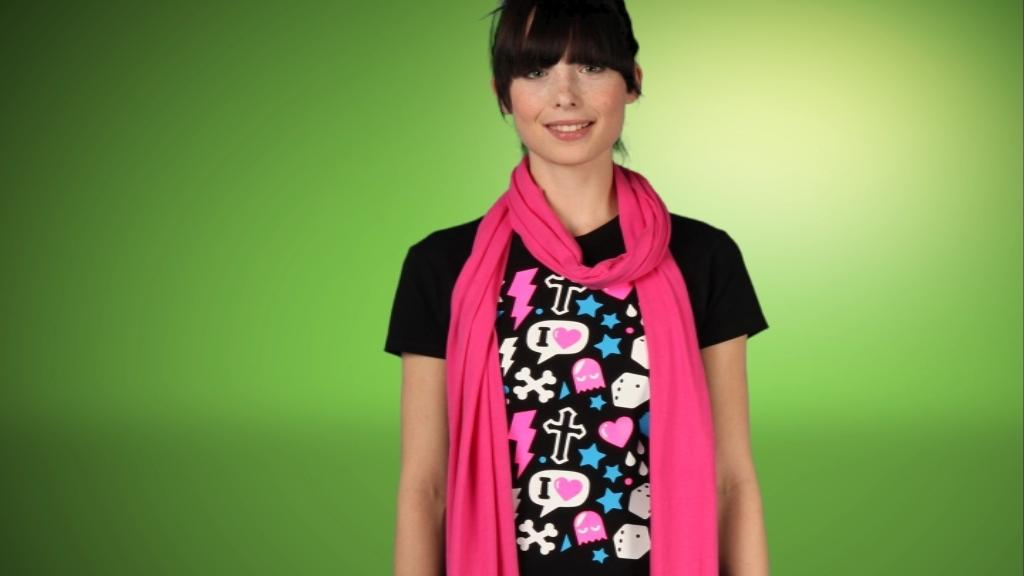Who is present in the image? There is a woman in the image. What is the woman doing in the image? The woman is standing in the image. What is the woman's facial expression in the image? The woman is smiling in the image. What is the woman wearing in the image? The woman is wearing a pink color scarf in the image. What can be seen in the background of the image? The background of the image is green. What type of potato can be seen in the woman's hand in the image? There is no potato present in the image; the woman is not holding anything in her hand. 